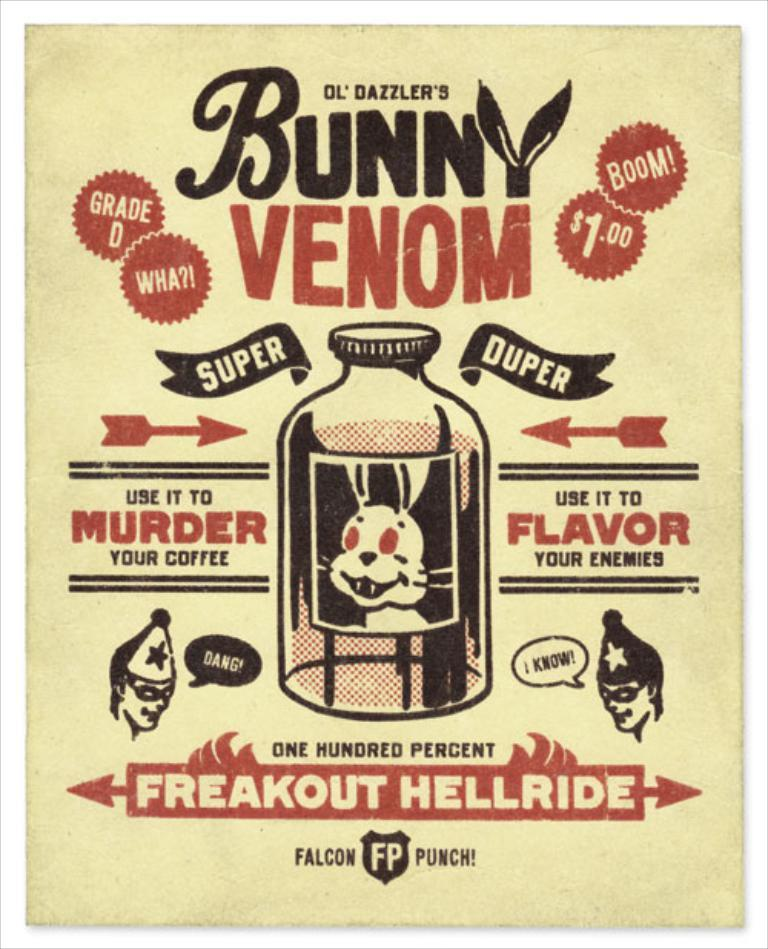What is present on the paper in the image? There are words and images on the paper in the image. Can you describe the content of the paper? The paper contains both words and images, but the specific content cannot be determined from the image alone. How does the dust affect the government in the image? There is no dust or government present in the image; it only features a paper with words and images. 